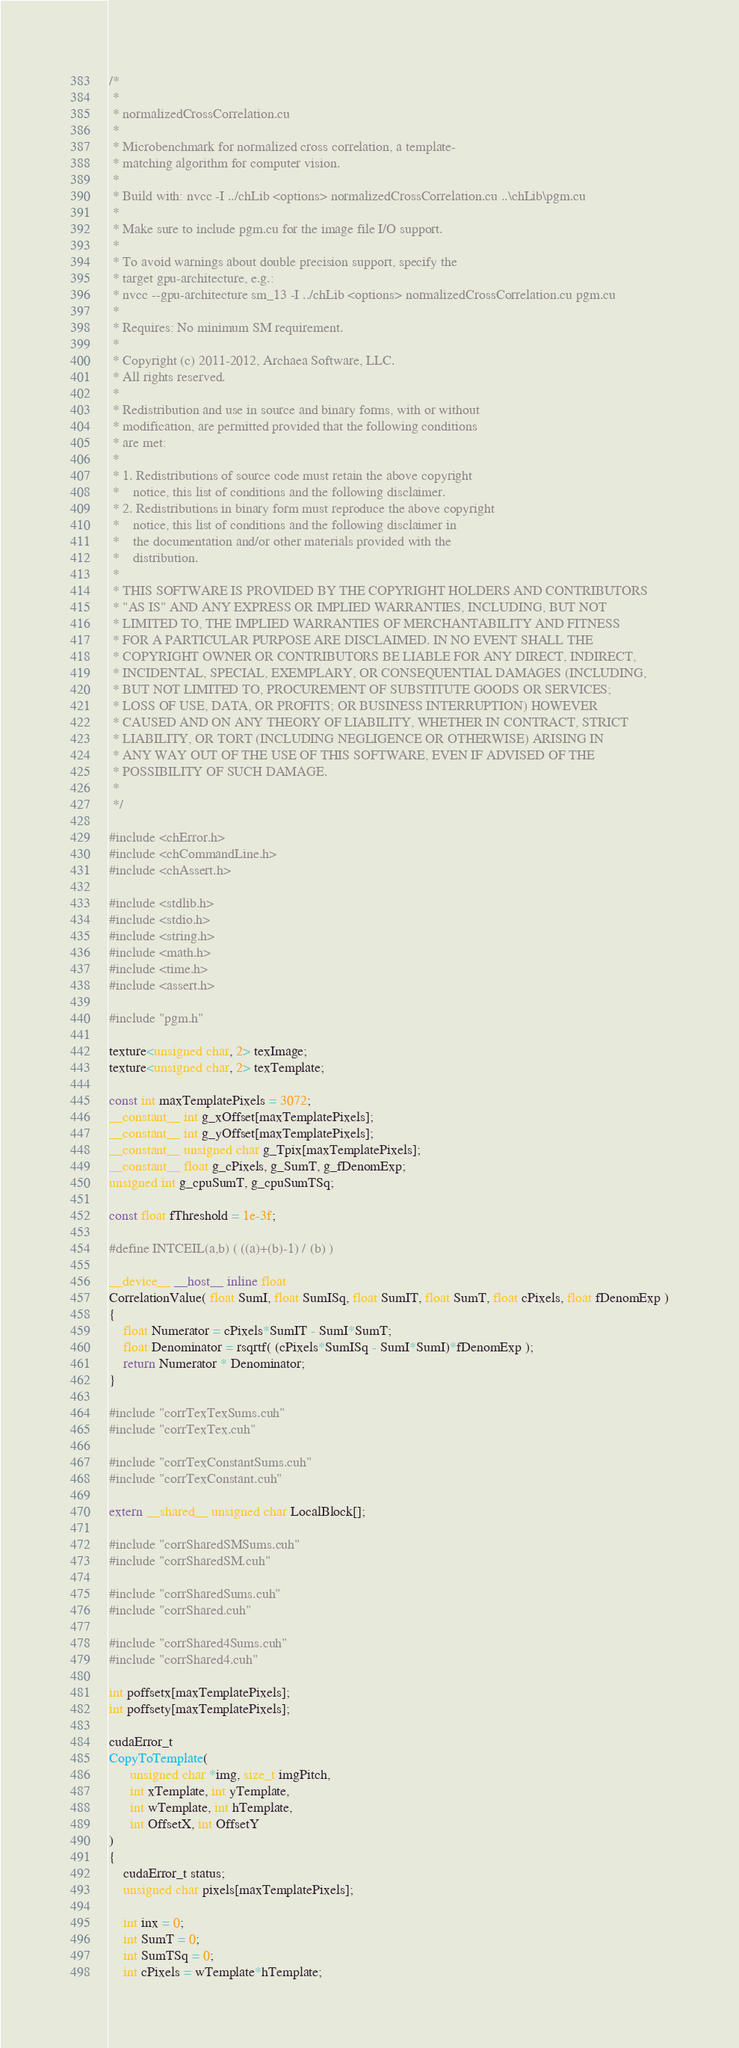<code> <loc_0><loc_0><loc_500><loc_500><_Cuda_>/*
 *
 * normalizedCrossCorrelation.cu
 *
 * Microbenchmark for normalized cross correlation, a template-
 * matching algorithm for computer vision.
 *
 * Build with: nvcc -I ../chLib <options> normalizedCrossCorrelation.cu ..\chLib\pgm.cu
 *
 * Make sure to include pgm.cu for the image file I/O support.
 *
 * To avoid warnings about double precision support, specify the
 * target gpu-architecture, e.g.:
 * nvcc --gpu-architecture sm_13 -I ../chLib <options> normalizedCrossCorrelation.cu pgm.cu
 *
 * Requires: No minimum SM requirement.
 *
 * Copyright (c) 2011-2012, Archaea Software, LLC.
 * All rights reserved.
 *
 * Redistribution and use in source and binary forms, with or without
 * modification, are permitted provided that the following conditions 
 * are met: 
 *
 * 1. Redistributions of source code must retain the above copyright 
 *    notice, this list of conditions and the following disclaimer. 
 * 2. Redistributions in binary form must reproduce the above copyright 
 *    notice, this list of conditions and the following disclaimer in 
 *    the documentation and/or other materials provided with the 
 *    distribution. 
 *
 * THIS SOFTWARE IS PROVIDED BY THE COPYRIGHT HOLDERS AND CONTRIBUTORS 
 * "AS IS" AND ANY EXPRESS OR IMPLIED WARRANTIES, INCLUDING, BUT NOT 
 * LIMITED TO, THE IMPLIED WARRANTIES OF MERCHANTABILITY AND FITNESS 
 * FOR A PARTICULAR PURPOSE ARE DISCLAIMED. IN NO EVENT SHALL THE 
 * COPYRIGHT OWNER OR CONTRIBUTORS BE LIABLE FOR ANY DIRECT, INDIRECT, 
 * INCIDENTAL, SPECIAL, EXEMPLARY, OR CONSEQUENTIAL DAMAGES (INCLUDING, 
 * BUT NOT LIMITED TO, PROCUREMENT OF SUBSTITUTE GOODS OR SERVICES;
 * LOSS OF USE, DATA, OR PROFITS; OR BUSINESS INTERRUPTION) HOWEVER 
 * CAUSED AND ON ANY THEORY OF LIABILITY, WHETHER IN CONTRACT, STRICT 
 * LIABILITY, OR TORT (INCLUDING NEGLIGENCE OR OTHERWISE) ARISING IN 
 * ANY WAY OUT OF THE USE OF THIS SOFTWARE, EVEN IF ADVISED OF THE 
 * POSSIBILITY OF SUCH DAMAGE.
 *
 */

#include <chError.h>
#include <chCommandLine.h>
#include <chAssert.h>

#include <stdlib.h>
#include <stdio.h>
#include <string.h>
#include <math.h>
#include <time.h>
#include <assert.h>

#include "pgm.h"

texture<unsigned char, 2> texImage;
texture<unsigned char, 2> texTemplate;

const int maxTemplatePixels = 3072;
__constant__ int g_xOffset[maxTemplatePixels];
__constant__ int g_yOffset[maxTemplatePixels];
__constant__ unsigned char g_Tpix[maxTemplatePixels];
__constant__ float g_cPixels, g_SumT, g_fDenomExp;
unsigned int g_cpuSumT, g_cpuSumTSq;

const float fThreshold = 1e-3f;

#define INTCEIL(a,b) ( ((a)+(b)-1) / (b) )

__device__ __host__ inline float
CorrelationValue( float SumI, float SumISq, float SumIT, float SumT, float cPixels, float fDenomExp )
{
    float Numerator = cPixels*SumIT - SumI*SumT;
    float Denominator = rsqrtf( (cPixels*SumISq - SumI*SumI)*fDenomExp );
    return Numerator * Denominator;
}

#include "corrTexTexSums.cuh"
#include "corrTexTex.cuh"

#include "corrTexConstantSums.cuh"
#include "corrTexConstant.cuh"

extern __shared__ unsigned char LocalBlock[];

#include "corrSharedSMSums.cuh"
#include "corrSharedSM.cuh"

#include "corrSharedSums.cuh"
#include "corrShared.cuh"

#include "corrShared4Sums.cuh"
#include "corrShared4.cuh"

int poffsetx[maxTemplatePixels];
int poffsety[maxTemplatePixels];

cudaError_t
CopyToTemplate( 
      unsigned char *img, size_t imgPitch, 
      int xTemplate, int yTemplate,
      int wTemplate, int hTemplate,
      int OffsetX, int OffsetY
)
{
    cudaError_t status;
    unsigned char pixels[maxTemplatePixels];

    int inx = 0;
    int SumT = 0;
    int SumTSq = 0;
    int cPixels = wTemplate*hTemplate;</code> 